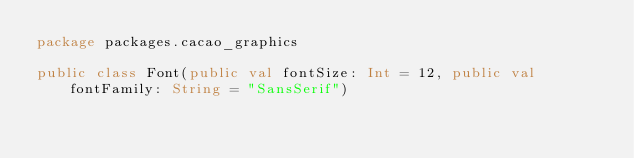Convert code to text. <code><loc_0><loc_0><loc_500><loc_500><_Kotlin_>package packages.cacao_graphics

public class Font(public val fontSize: Int = 12, public val fontFamily: String = "SansSerif")
</code> 